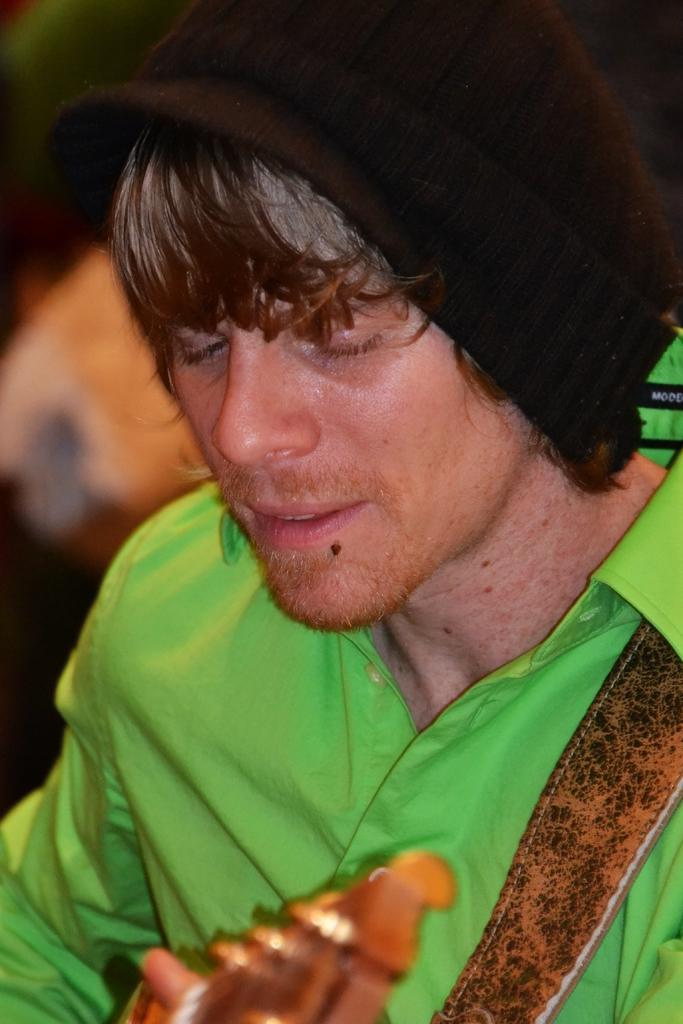Who is the main subject in the image? There is a man in the center of the image. What is the man holding in his hand? The man is holding a musical instrument in his hand. What can be seen on the man's head? The man is wearing a black color hat. How many wings does the coach have in the image? There is no coach present in the image, so it is not possible to determine the number of wings it might have. 